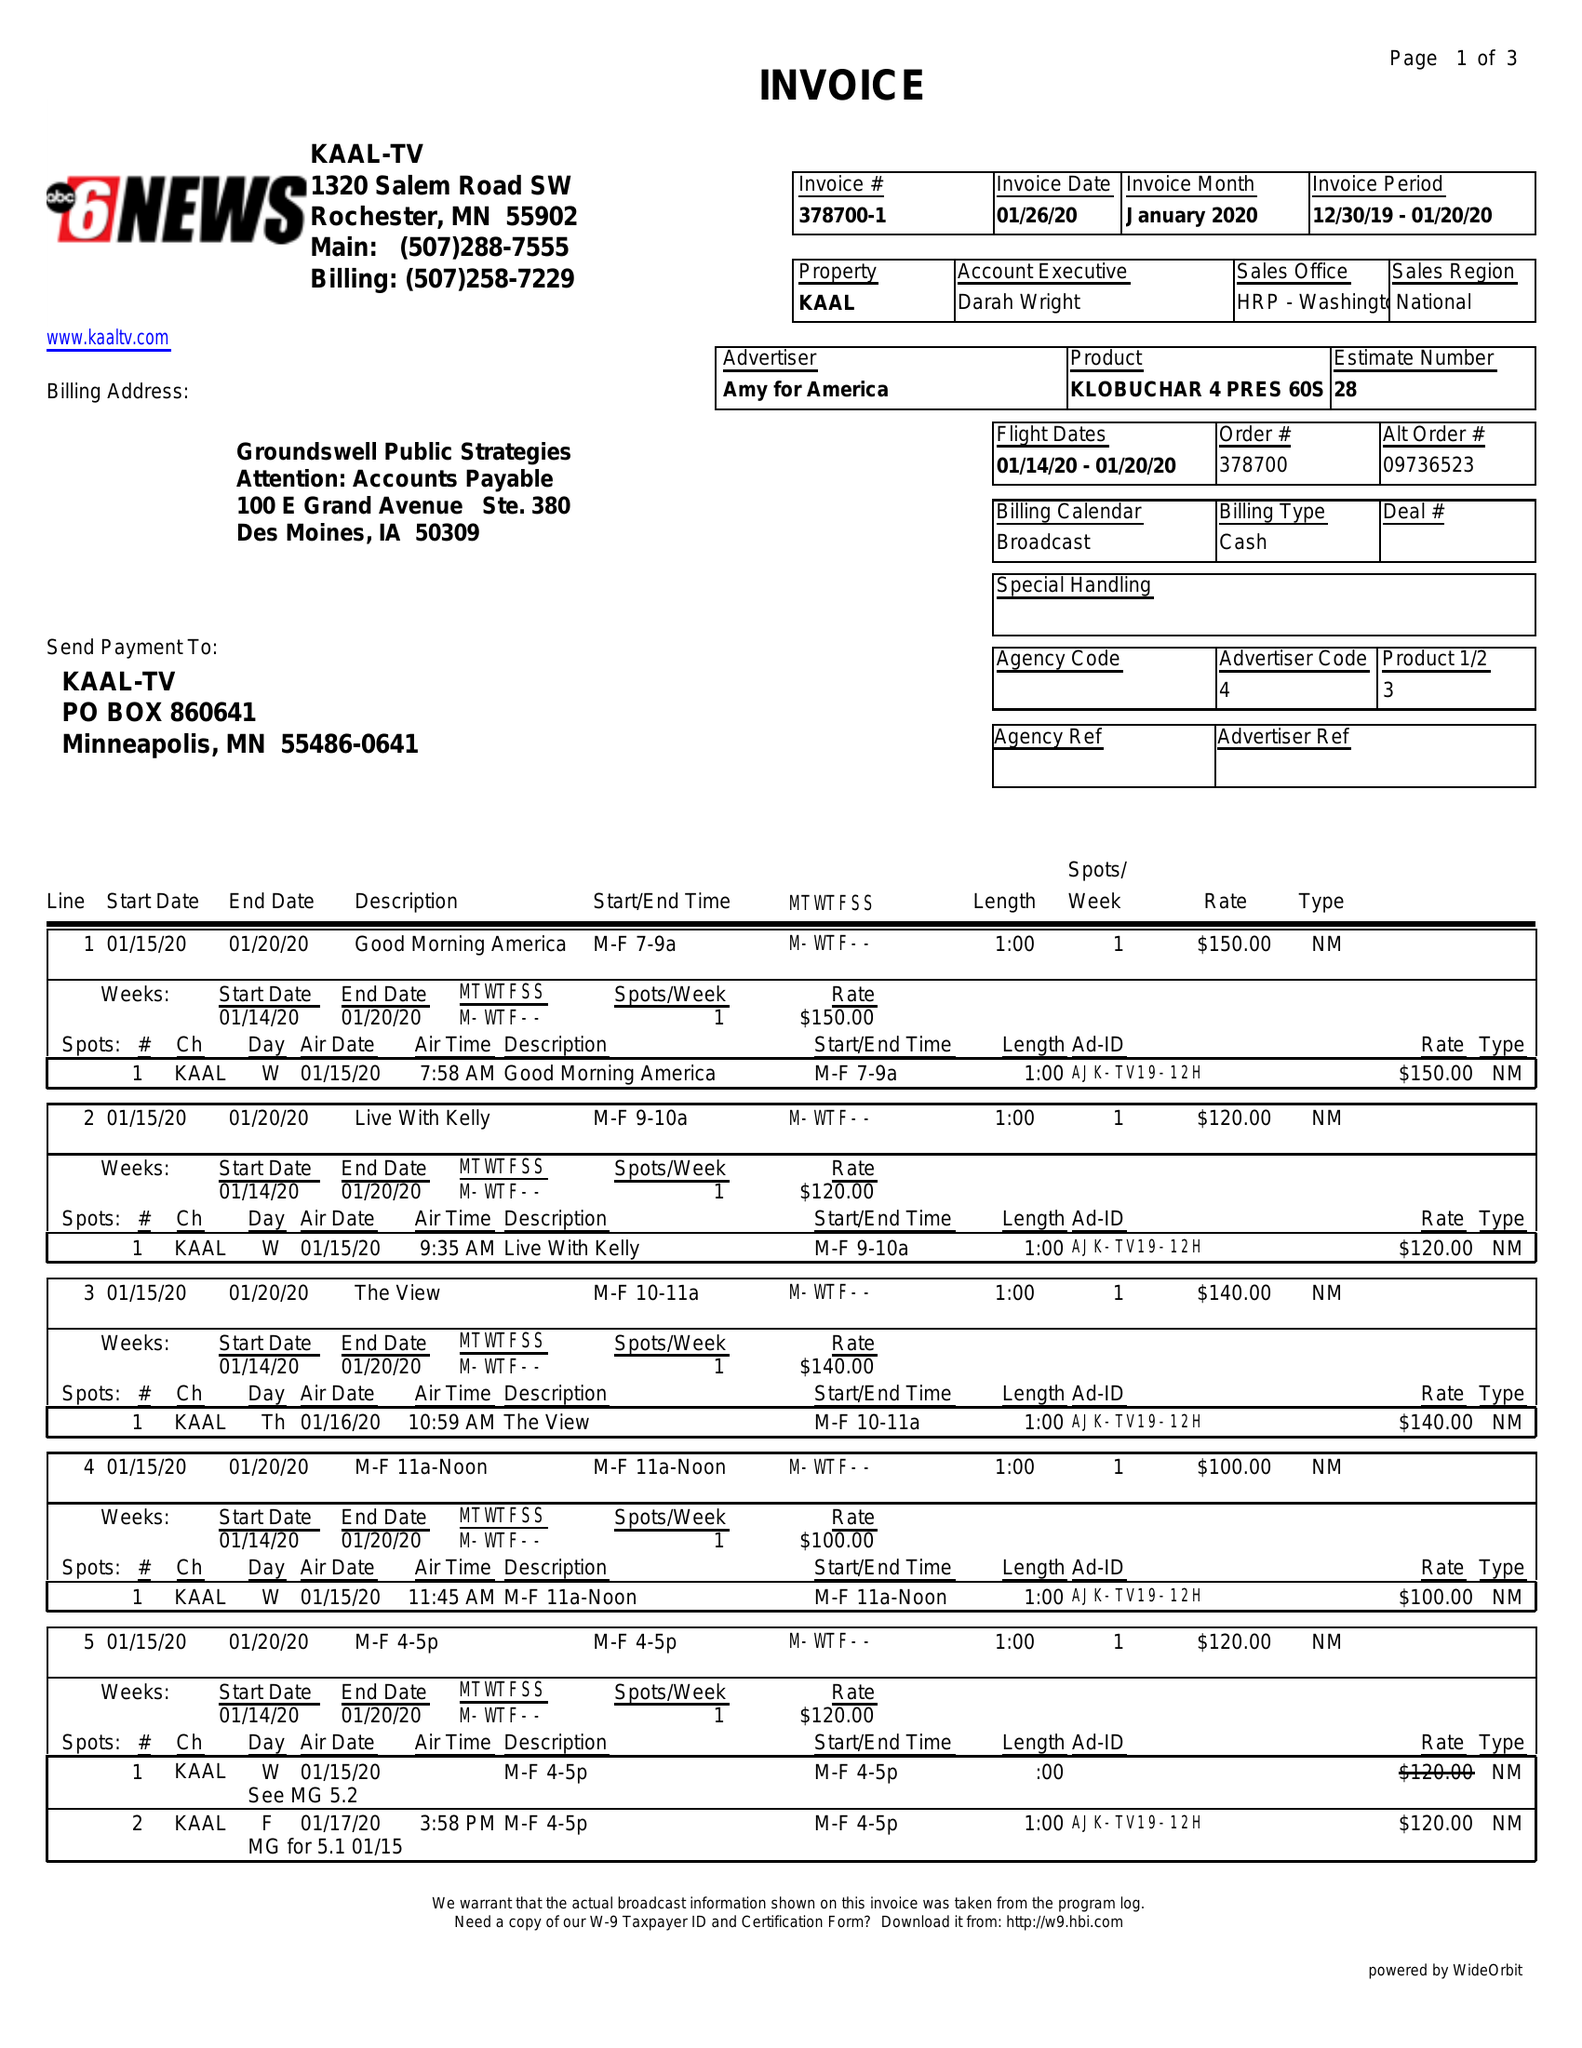What is the value for the advertiser?
Answer the question using a single word or phrase. AMY FOR AMERICA 